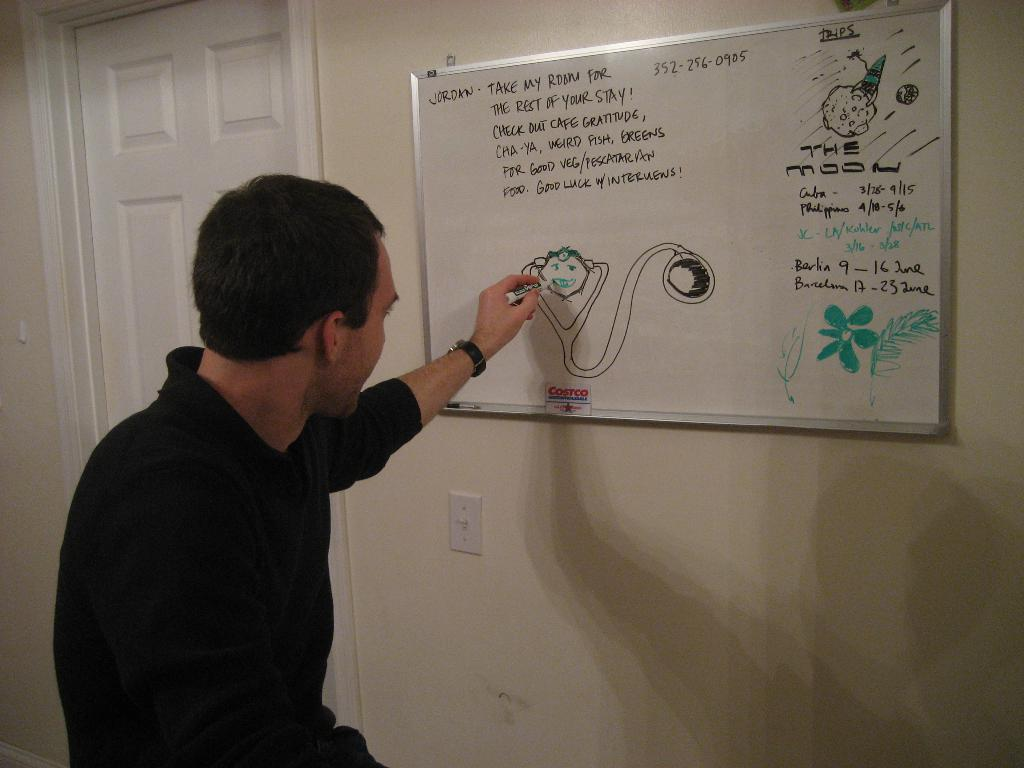<image>
Describe the image concisely. A man drawing on a white board that says Jordan take my room for the rest of your stay! 